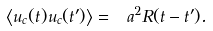<formula> <loc_0><loc_0><loc_500><loc_500>\left < u _ { c } ( t ) u _ { c } ( t ^ { \prime } ) \right > = \ a ^ { 2 } R ( t - t ^ { \prime } ) .</formula> 